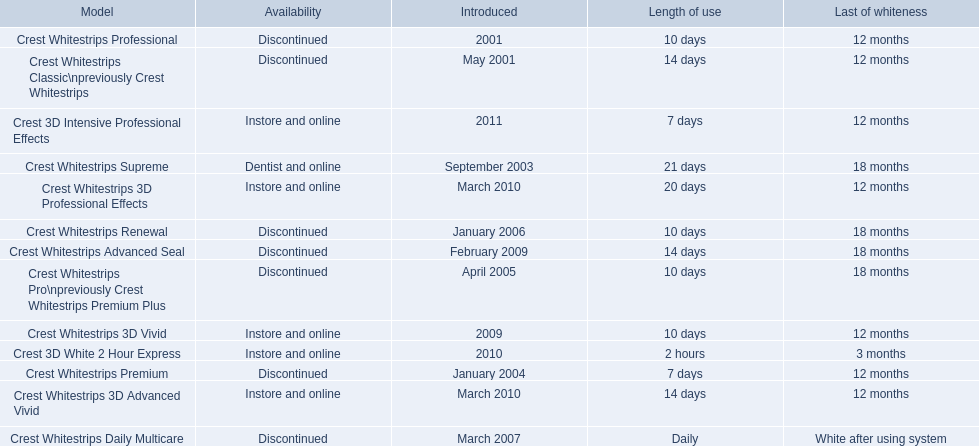When was crest whitestrips 3d advanced vivid introduced? March 2010. What other product was introduced in march 2010? Crest Whitestrips 3D Professional Effects. 